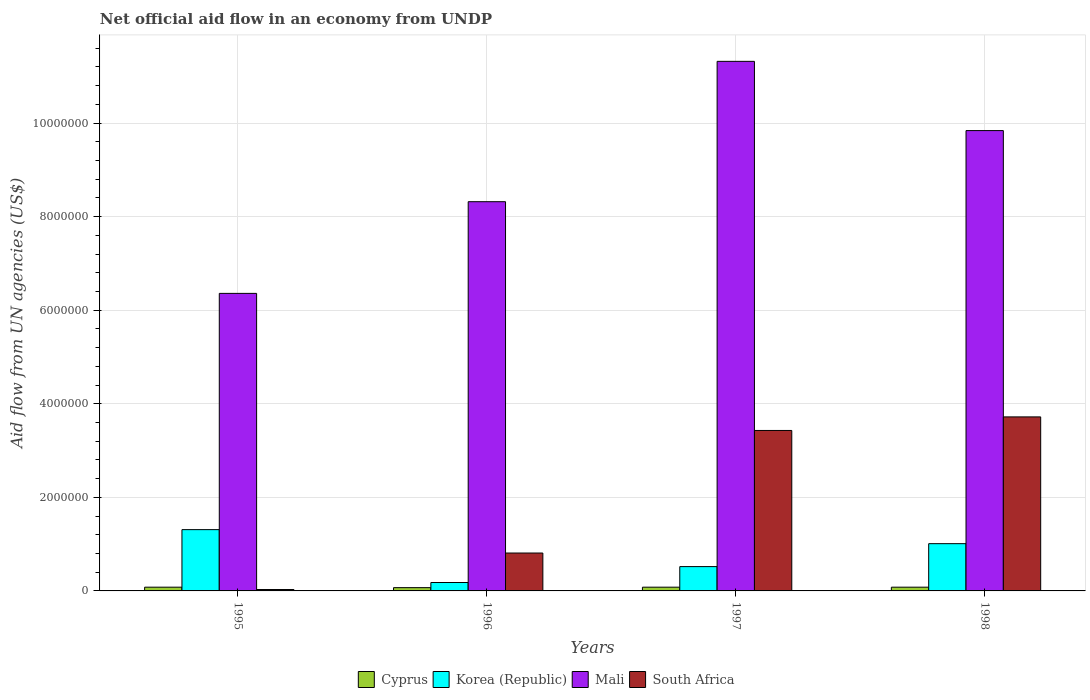Are the number of bars per tick equal to the number of legend labels?
Ensure brevity in your answer.  Yes. Are the number of bars on each tick of the X-axis equal?
Offer a terse response. Yes. What is the label of the 4th group of bars from the left?
Give a very brief answer. 1998. In how many cases, is the number of bars for a given year not equal to the number of legend labels?
Your answer should be compact. 0. What is the net official aid flow in Mali in 1997?
Keep it short and to the point. 1.13e+07. Across all years, what is the maximum net official aid flow in Korea (Republic)?
Ensure brevity in your answer.  1.31e+06. In which year was the net official aid flow in South Africa maximum?
Your answer should be compact. 1998. What is the total net official aid flow in Korea (Republic) in the graph?
Give a very brief answer. 3.02e+06. What is the difference between the net official aid flow in Mali in 1997 and the net official aid flow in South Africa in 1996?
Provide a succinct answer. 1.05e+07. What is the average net official aid flow in Mali per year?
Ensure brevity in your answer.  8.96e+06. In the year 1995, what is the difference between the net official aid flow in South Africa and net official aid flow in Korea (Republic)?
Provide a short and direct response. -1.28e+06. What is the ratio of the net official aid flow in Mali in 1995 to that in 1998?
Give a very brief answer. 0.65. Is the net official aid flow in Cyprus in 1997 less than that in 1998?
Give a very brief answer. No. What is the difference between the highest and the second highest net official aid flow in Mali?
Provide a succinct answer. 1.48e+06. What is the difference between the highest and the lowest net official aid flow in South Africa?
Provide a succinct answer. 3.69e+06. In how many years, is the net official aid flow in South Africa greater than the average net official aid flow in South Africa taken over all years?
Ensure brevity in your answer.  2. Is the sum of the net official aid flow in South Africa in 1995 and 1996 greater than the maximum net official aid flow in Korea (Republic) across all years?
Keep it short and to the point. No. Is it the case that in every year, the sum of the net official aid flow in Mali and net official aid flow in South Africa is greater than the sum of net official aid flow in Cyprus and net official aid flow in Korea (Republic)?
Keep it short and to the point. Yes. What does the 1st bar from the left in 1998 represents?
Give a very brief answer. Cyprus. What does the 3rd bar from the right in 1997 represents?
Give a very brief answer. Korea (Republic). Are all the bars in the graph horizontal?
Provide a succinct answer. No. What is the difference between two consecutive major ticks on the Y-axis?
Keep it short and to the point. 2.00e+06. Does the graph contain any zero values?
Keep it short and to the point. No. Does the graph contain grids?
Provide a short and direct response. Yes. How are the legend labels stacked?
Keep it short and to the point. Horizontal. What is the title of the graph?
Ensure brevity in your answer.  Net official aid flow in an economy from UNDP. What is the label or title of the Y-axis?
Offer a terse response. Aid flow from UN agencies (US$). What is the Aid flow from UN agencies (US$) of Korea (Republic) in 1995?
Offer a terse response. 1.31e+06. What is the Aid flow from UN agencies (US$) in Mali in 1995?
Your response must be concise. 6.36e+06. What is the Aid flow from UN agencies (US$) in South Africa in 1995?
Ensure brevity in your answer.  3.00e+04. What is the Aid flow from UN agencies (US$) of Mali in 1996?
Keep it short and to the point. 8.32e+06. What is the Aid flow from UN agencies (US$) in South Africa in 1996?
Make the answer very short. 8.10e+05. What is the Aid flow from UN agencies (US$) in Korea (Republic) in 1997?
Your answer should be compact. 5.20e+05. What is the Aid flow from UN agencies (US$) of Mali in 1997?
Keep it short and to the point. 1.13e+07. What is the Aid flow from UN agencies (US$) in South Africa in 1997?
Give a very brief answer. 3.43e+06. What is the Aid flow from UN agencies (US$) of Korea (Republic) in 1998?
Offer a very short reply. 1.01e+06. What is the Aid flow from UN agencies (US$) in Mali in 1998?
Your answer should be very brief. 9.84e+06. What is the Aid flow from UN agencies (US$) of South Africa in 1998?
Ensure brevity in your answer.  3.72e+06. Across all years, what is the maximum Aid flow from UN agencies (US$) of Korea (Republic)?
Your response must be concise. 1.31e+06. Across all years, what is the maximum Aid flow from UN agencies (US$) of Mali?
Your answer should be compact. 1.13e+07. Across all years, what is the maximum Aid flow from UN agencies (US$) in South Africa?
Offer a very short reply. 3.72e+06. Across all years, what is the minimum Aid flow from UN agencies (US$) in Cyprus?
Provide a short and direct response. 7.00e+04. Across all years, what is the minimum Aid flow from UN agencies (US$) in Mali?
Make the answer very short. 6.36e+06. What is the total Aid flow from UN agencies (US$) in Cyprus in the graph?
Give a very brief answer. 3.10e+05. What is the total Aid flow from UN agencies (US$) in Korea (Republic) in the graph?
Provide a succinct answer. 3.02e+06. What is the total Aid flow from UN agencies (US$) of Mali in the graph?
Offer a terse response. 3.58e+07. What is the total Aid flow from UN agencies (US$) of South Africa in the graph?
Your answer should be very brief. 7.99e+06. What is the difference between the Aid flow from UN agencies (US$) of Cyprus in 1995 and that in 1996?
Provide a short and direct response. 10000. What is the difference between the Aid flow from UN agencies (US$) in Korea (Republic) in 1995 and that in 1996?
Make the answer very short. 1.13e+06. What is the difference between the Aid flow from UN agencies (US$) of Mali in 1995 and that in 1996?
Your answer should be compact. -1.96e+06. What is the difference between the Aid flow from UN agencies (US$) of South Africa in 1995 and that in 1996?
Make the answer very short. -7.80e+05. What is the difference between the Aid flow from UN agencies (US$) of Korea (Republic) in 1995 and that in 1997?
Provide a succinct answer. 7.90e+05. What is the difference between the Aid flow from UN agencies (US$) of Mali in 1995 and that in 1997?
Offer a terse response. -4.96e+06. What is the difference between the Aid flow from UN agencies (US$) of South Africa in 1995 and that in 1997?
Your response must be concise. -3.40e+06. What is the difference between the Aid flow from UN agencies (US$) in Mali in 1995 and that in 1998?
Provide a short and direct response. -3.48e+06. What is the difference between the Aid flow from UN agencies (US$) in South Africa in 1995 and that in 1998?
Make the answer very short. -3.69e+06. What is the difference between the Aid flow from UN agencies (US$) in Korea (Republic) in 1996 and that in 1997?
Keep it short and to the point. -3.40e+05. What is the difference between the Aid flow from UN agencies (US$) of South Africa in 1996 and that in 1997?
Give a very brief answer. -2.62e+06. What is the difference between the Aid flow from UN agencies (US$) of Korea (Republic) in 1996 and that in 1998?
Provide a succinct answer. -8.30e+05. What is the difference between the Aid flow from UN agencies (US$) in Mali in 1996 and that in 1998?
Provide a short and direct response. -1.52e+06. What is the difference between the Aid flow from UN agencies (US$) in South Africa in 1996 and that in 1998?
Provide a succinct answer. -2.91e+06. What is the difference between the Aid flow from UN agencies (US$) of Cyprus in 1997 and that in 1998?
Provide a succinct answer. 0. What is the difference between the Aid flow from UN agencies (US$) in Korea (Republic) in 1997 and that in 1998?
Your answer should be very brief. -4.90e+05. What is the difference between the Aid flow from UN agencies (US$) of Mali in 1997 and that in 1998?
Your response must be concise. 1.48e+06. What is the difference between the Aid flow from UN agencies (US$) of South Africa in 1997 and that in 1998?
Your response must be concise. -2.90e+05. What is the difference between the Aid flow from UN agencies (US$) of Cyprus in 1995 and the Aid flow from UN agencies (US$) of Mali in 1996?
Offer a terse response. -8.24e+06. What is the difference between the Aid flow from UN agencies (US$) in Cyprus in 1995 and the Aid flow from UN agencies (US$) in South Africa in 1996?
Offer a terse response. -7.30e+05. What is the difference between the Aid flow from UN agencies (US$) of Korea (Republic) in 1995 and the Aid flow from UN agencies (US$) of Mali in 1996?
Provide a short and direct response. -7.01e+06. What is the difference between the Aid flow from UN agencies (US$) of Korea (Republic) in 1995 and the Aid flow from UN agencies (US$) of South Africa in 1996?
Offer a very short reply. 5.00e+05. What is the difference between the Aid flow from UN agencies (US$) in Mali in 1995 and the Aid flow from UN agencies (US$) in South Africa in 1996?
Offer a terse response. 5.55e+06. What is the difference between the Aid flow from UN agencies (US$) in Cyprus in 1995 and the Aid flow from UN agencies (US$) in Korea (Republic) in 1997?
Provide a short and direct response. -4.40e+05. What is the difference between the Aid flow from UN agencies (US$) in Cyprus in 1995 and the Aid flow from UN agencies (US$) in Mali in 1997?
Provide a short and direct response. -1.12e+07. What is the difference between the Aid flow from UN agencies (US$) in Cyprus in 1995 and the Aid flow from UN agencies (US$) in South Africa in 1997?
Your response must be concise. -3.35e+06. What is the difference between the Aid flow from UN agencies (US$) in Korea (Republic) in 1995 and the Aid flow from UN agencies (US$) in Mali in 1997?
Ensure brevity in your answer.  -1.00e+07. What is the difference between the Aid flow from UN agencies (US$) in Korea (Republic) in 1995 and the Aid flow from UN agencies (US$) in South Africa in 1997?
Offer a very short reply. -2.12e+06. What is the difference between the Aid flow from UN agencies (US$) of Mali in 1995 and the Aid flow from UN agencies (US$) of South Africa in 1997?
Keep it short and to the point. 2.93e+06. What is the difference between the Aid flow from UN agencies (US$) in Cyprus in 1995 and the Aid flow from UN agencies (US$) in Korea (Republic) in 1998?
Make the answer very short. -9.30e+05. What is the difference between the Aid flow from UN agencies (US$) in Cyprus in 1995 and the Aid flow from UN agencies (US$) in Mali in 1998?
Your answer should be compact. -9.76e+06. What is the difference between the Aid flow from UN agencies (US$) in Cyprus in 1995 and the Aid flow from UN agencies (US$) in South Africa in 1998?
Your response must be concise. -3.64e+06. What is the difference between the Aid flow from UN agencies (US$) in Korea (Republic) in 1995 and the Aid flow from UN agencies (US$) in Mali in 1998?
Your answer should be very brief. -8.53e+06. What is the difference between the Aid flow from UN agencies (US$) in Korea (Republic) in 1995 and the Aid flow from UN agencies (US$) in South Africa in 1998?
Give a very brief answer. -2.41e+06. What is the difference between the Aid flow from UN agencies (US$) of Mali in 1995 and the Aid flow from UN agencies (US$) of South Africa in 1998?
Keep it short and to the point. 2.64e+06. What is the difference between the Aid flow from UN agencies (US$) of Cyprus in 1996 and the Aid flow from UN agencies (US$) of Korea (Republic) in 1997?
Give a very brief answer. -4.50e+05. What is the difference between the Aid flow from UN agencies (US$) of Cyprus in 1996 and the Aid flow from UN agencies (US$) of Mali in 1997?
Your answer should be compact. -1.12e+07. What is the difference between the Aid flow from UN agencies (US$) of Cyprus in 1996 and the Aid flow from UN agencies (US$) of South Africa in 1997?
Provide a short and direct response. -3.36e+06. What is the difference between the Aid flow from UN agencies (US$) of Korea (Republic) in 1996 and the Aid flow from UN agencies (US$) of Mali in 1997?
Provide a short and direct response. -1.11e+07. What is the difference between the Aid flow from UN agencies (US$) of Korea (Republic) in 1996 and the Aid flow from UN agencies (US$) of South Africa in 1997?
Provide a short and direct response. -3.25e+06. What is the difference between the Aid flow from UN agencies (US$) of Mali in 1996 and the Aid flow from UN agencies (US$) of South Africa in 1997?
Ensure brevity in your answer.  4.89e+06. What is the difference between the Aid flow from UN agencies (US$) of Cyprus in 1996 and the Aid flow from UN agencies (US$) of Korea (Republic) in 1998?
Your response must be concise. -9.40e+05. What is the difference between the Aid flow from UN agencies (US$) of Cyprus in 1996 and the Aid flow from UN agencies (US$) of Mali in 1998?
Provide a succinct answer. -9.77e+06. What is the difference between the Aid flow from UN agencies (US$) in Cyprus in 1996 and the Aid flow from UN agencies (US$) in South Africa in 1998?
Keep it short and to the point. -3.65e+06. What is the difference between the Aid flow from UN agencies (US$) of Korea (Republic) in 1996 and the Aid flow from UN agencies (US$) of Mali in 1998?
Offer a terse response. -9.66e+06. What is the difference between the Aid flow from UN agencies (US$) in Korea (Republic) in 1996 and the Aid flow from UN agencies (US$) in South Africa in 1998?
Make the answer very short. -3.54e+06. What is the difference between the Aid flow from UN agencies (US$) of Mali in 1996 and the Aid flow from UN agencies (US$) of South Africa in 1998?
Offer a very short reply. 4.60e+06. What is the difference between the Aid flow from UN agencies (US$) in Cyprus in 1997 and the Aid flow from UN agencies (US$) in Korea (Republic) in 1998?
Ensure brevity in your answer.  -9.30e+05. What is the difference between the Aid flow from UN agencies (US$) of Cyprus in 1997 and the Aid flow from UN agencies (US$) of Mali in 1998?
Provide a short and direct response. -9.76e+06. What is the difference between the Aid flow from UN agencies (US$) of Cyprus in 1997 and the Aid flow from UN agencies (US$) of South Africa in 1998?
Provide a succinct answer. -3.64e+06. What is the difference between the Aid flow from UN agencies (US$) in Korea (Republic) in 1997 and the Aid flow from UN agencies (US$) in Mali in 1998?
Offer a terse response. -9.32e+06. What is the difference between the Aid flow from UN agencies (US$) in Korea (Republic) in 1997 and the Aid flow from UN agencies (US$) in South Africa in 1998?
Your answer should be compact. -3.20e+06. What is the difference between the Aid flow from UN agencies (US$) in Mali in 1997 and the Aid flow from UN agencies (US$) in South Africa in 1998?
Your answer should be very brief. 7.60e+06. What is the average Aid flow from UN agencies (US$) of Cyprus per year?
Offer a very short reply. 7.75e+04. What is the average Aid flow from UN agencies (US$) in Korea (Republic) per year?
Ensure brevity in your answer.  7.55e+05. What is the average Aid flow from UN agencies (US$) in Mali per year?
Your response must be concise. 8.96e+06. What is the average Aid flow from UN agencies (US$) of South Africa per year?
Offer a very short reply. 2.00e+06. In the year 1995, what is the difference between the Aid flow from UN agencies (US$) in Cyprus and Aid flow from UN agencies (US$) in Korea (Republic)?
Give a very brief answer. -1.23e+06. In the year 1995, what is the difference between the Aid flow from UN agencies (US$) of Cyprus and Aid flow from UN agencies (US$) of Mali?
Your answer should be very brief. -6.28e+06. In the year 1995, what is the difference between the Aid flow from UN agencies (US$) of Cyprus and Aid flow from UN agencies (US$) of South Africa?
Offer a terse response. 5.00e+04. In the year 1995, what is the difference between the Aid flow from UN agencies (US$) in Korea (Republic) and Aid flow from UN agencies (US$) in Mali?
Your answer should be compact. -5.05e+06. In the year 1995, what is the difference between the Aid flow from UN agencies (US$) of Korea (Republic) and Aid flow from UN agencies (US$) of South Africa?
Offer a terse response. 1.28e+06. In the year 1995, what is the difference between the Aid flow from UN agencies (US$) of Mali and Aid flow from UN agencies (US$) of South Africa?
Your response must be concise. 6.33e+06. In the year 1996, what is the difference between the Aid flow from UN agencies (US$) in Cyprus and Aid flow from UN agencies (US$) in Mali?
Keep it short and to the point. -8.25e+06. In the year 1996, what is the difference between the Aid flow from UN agencies (US$) of Cyprus and Aid flow from UN agencies (US$) of South Africa?
Offer a very short reply. -7.40e+05. In the year 1996, what is the difference between the Aid flow from UN agencies (US$) in Korea (Republic) and Aid flow from UN agencies (US$) in Mali?
Your answer should be very brief. -8.14e+06. In the year 1996, what is the difference between the Aid flow from UN agencies (US$) in Korea (Republic) and Aid flow from UN agencies (US$) in South Africa?
Your response must be concise. -6.30e+05. In the year 1996, what is the difference between the Aid flow from UN agencies (US$) in Mali and Aid flow from UN agencies (US$) in South Africa?
Give a very brief answer. 7.51e+06. In the year 1997, what is the difference between the Aid flow from UN agencies (US$) in Cyprus and Aid flow from UN agencies (US$) in Korea (Republic)?
Ensure brevity in your answer.  -4.40e+05. In the year 1997, what is the difference between the Aid flow from UN agencies (US$) of Cyprus and Aid flow from UN agencies (US$) of Mali?
Make the answer very short. -1.12e+07. In the year 1997, what is the difference between the Aid flow from UN agencies (US$) in Cyprus and Aid flow from UN agencies (US$) in South Africa?
Your response must be concise. -3.35e+06. In the year 1997, what is the difference between the Aid flow from UN agencies (US$) in Korea (Republic) and Aid flow from UN agencies (US$) in Mali?
Your answer should be very brief. -1.08e+07. In the year 1997, what is the difference between the Aid flow from UN agencies (US$) of Korea (Republic) and Aid flow from UN agencies (US$) of South Africa?
Offer a very short reply. -2.91e+06. In the year 1997, what is the difference between the Aid flow from UN agencies (US$) in Mali and Aid flow from UN agencies (US$) in South Africa?
Make the answer very short. 7.89e+06. In the year 1998, what is the difference between the Aid flow from UN agencies (US$) in Cyprus and Aid flow from UN agencies (US$) in Korea (Republic)?
Offer a very short reply. -9.30e+05. In the year 1998, what is the difference between the Aid flow from UN agencies (US$) in Cyprus and Aid flow from UN agencies (US$) in Mali?
Your answer should be compact. -9.76e+06. In the year 1998, what is the difference between the Aid flow from UN agencies (US$) in Cyprus and Aid flow from UN agencies (US$) in South Africa?
Offer a terse response. -3.64e+06. In the year 1998, what is the difference between the Aid flow from UN agencies (US$) of Korea (Republic) and Aid flow from UN agencies (US$) of Mali?
Make the answer very short. -8.83e+06. In the year 1998, what is the difference between the Aid flow from UN agencies (US$) in Korea (Republic) and Aid flow from UN agencies (US$) in South Africa?
Make the answer very short. -2.71e+06. In the year 1998, what is the difference between the Aid flow from UN agencies (US$) of Mali and Aid flow from UN agencies (US$) of South Africa?
Your response must be concise. 6.12e+06. What is the ratio of the Aid flow from UN agencies (US$) in Cyprus in 1995 to that in 1996?
Keep it short and to the point. 1.14. What is the ratio of the Aid flow from UN agencies (US$) of Korea (Republic) in 1995 to that in 1996?
Your answer should be compact. 7.28. What is the ratio of the Aid flow from UN agencies (US$) in Mali in 1995 to that in 1996?
Keep it short and to the point. 0.76. What is the ratio of the Aid flow from UN agencies (US$) of South Africa in 1995 to that in 1996?
Provide a short and direct response. 0.04. What is the ratio of the Aid flow from UN agencies (US$) in Cyprus in 1995 to that in 1997?
Your answer should be very brief. 1. What is the ratio of the Aid flow from UN agencies (US$) of Korea (Republic) in 1995 to that in 1997?
Your response must be concise. 2.52. What is the ratio of the Aid flow from UN agencies (US$) of Mali in 1995 to that in 1997?
Offer a very short reply. 0.56. What is the ratio of the Aid flow from UN agencies (US$) in South Africa in 1995 to that in 1997?
Ensure brevity in your answer.  0.01. What is the ratio of the Aid flow from UN agencies (US$) in Korea (Republic) in 1995 to that in 1998?
Keep it short and to the point. 1.3. What is the ratio of the Aid flow from UN agencies (US$) of Mali in 1995 to that in 1998?
Your response must be concise. 0.65. What is the ratio of the Aid flow from UN agencies (US$) in South Africa in 1995 to that in 1998?
Make the answer very short. 0.01. What is the ratio of the Aid flow from UN agencies (US$) in Cyprus in 1996 to that in 1997?
Your response must be concise. 0.88. What is the ratio of the Aid flow from UN agencies (US$) in Korea (Republic) in 1996 to that in 1997?
Provide a succinct answer. 0.35. What is the ratio of the Aid flow from UN agencies (US$) in Mali in 1996 to that in 1997?
Give a very brief answer. 0.73. What is the ratio of the Aid flow from UN agencies (US$) of South Africa in 1996 to that in 1997?
Offer a terse response. 0.24. What is the ratio of the Aid flow from UN agencies (US$) in Korea (Republic) in 1996 to that in 1998?
Your answer should be very brief. 0.18. What is the ratio of the Aid flow from UN agencies (US$) in Mali in 1996 to that in 1998?
Make the answer very short. 0.85. What is the ratio of the Aid flow from UN agencies (US$) of South Africa in 1996 to that in 1998?
Ensure brevity in your answer.  0.22. What is the ratio of the Aid flow from UN agencies (US$) of Korea (Republic) in 1997 to that in 1998?
Keep it short and to the point. 0.51. What is the ratio of the Aid flow from UN agencies (US$) in Mali in 1997 to that in 1998?
Offer a very short reply. 1.15. What is the ratio of the Aid flow from UN agencies (US$) of South Africa in 1997 to that in 1998?
Offer a terse response. 0.92. What is the difference between the highest and the second highest Aid flow from UN agencies (US$) of Cyprus?
Offer a very short reply. 0. What is the difference between the highest and the second highest Aid flow from UN agencies (US$) of Mali?
Your response must be concise. 1.48e+06. What is the difference between the highest and the second highest Aid flow from UN agencies (US$) in South Africa?
Offer a terse response. 2.90e+05. What is the difference between the highest and the lowest Aid flow from UN agencies (US$) of Korea (Republic)?
Your answer should be compact. 1.13e+06. What is the difference between the highest and the lowest Aid flow from UN agencies (US$) of Mali?
Ensure brevity in your answer.  4.96e+06. What is the difference between the highest and the lowest Aid flow from UN agencies (US$) in South Africa?
Provide a succinct answer. 3.69e+06. 